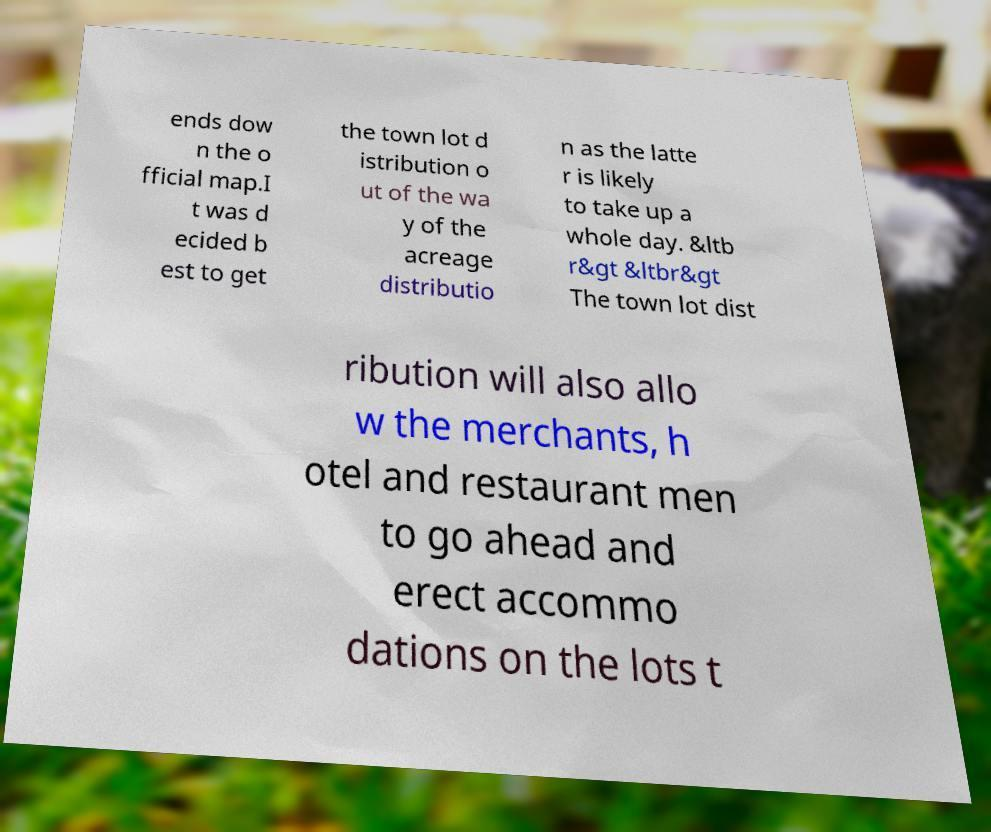There's text embedded in this image that I need extracted. Can you transcribe it verbatim? ends dow n the o fficial map.I t was d ecided b est to get the town lot d istribution o ut of the wa y of the acreage distributio n as the latte r is likely to take up a whole day. &ltb r&gt &ltbr&gt The town lot dist ribution will also allo w the merchants, h otel and restaurant men to go ahead and erect accommo dations on the lots t 